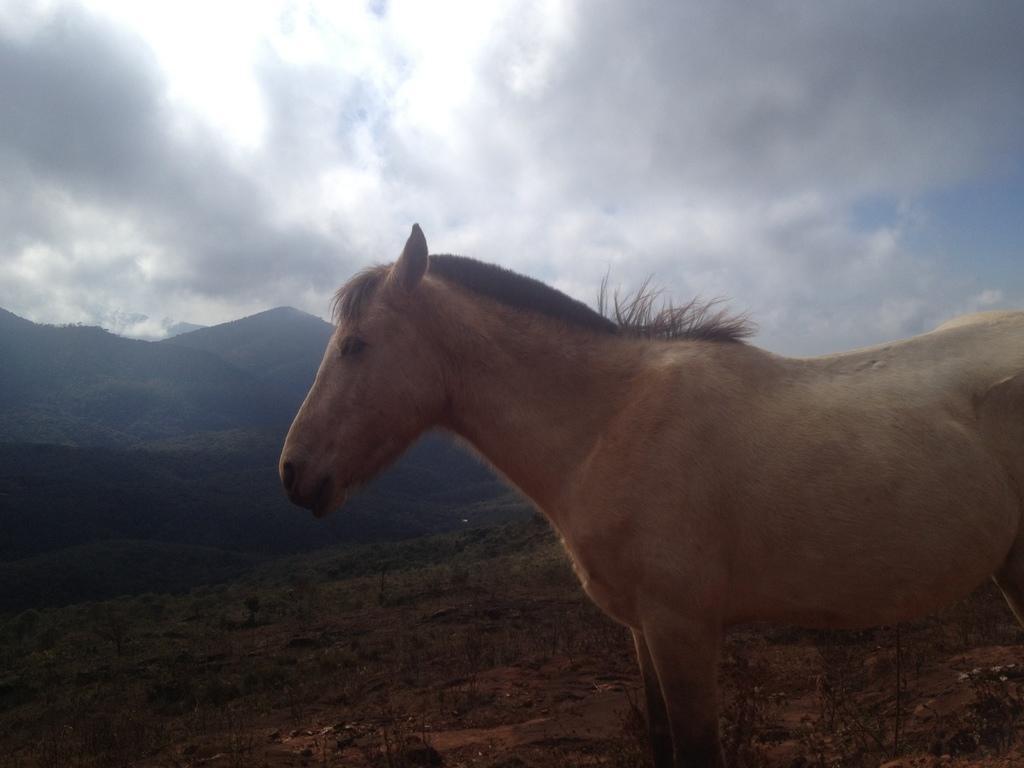Please provide a concise description of this image. On the right side of this image I can see a horse which is facing at the left side. In the background there are some trees and hills. On the top of the image I can see the sky and clouds. 